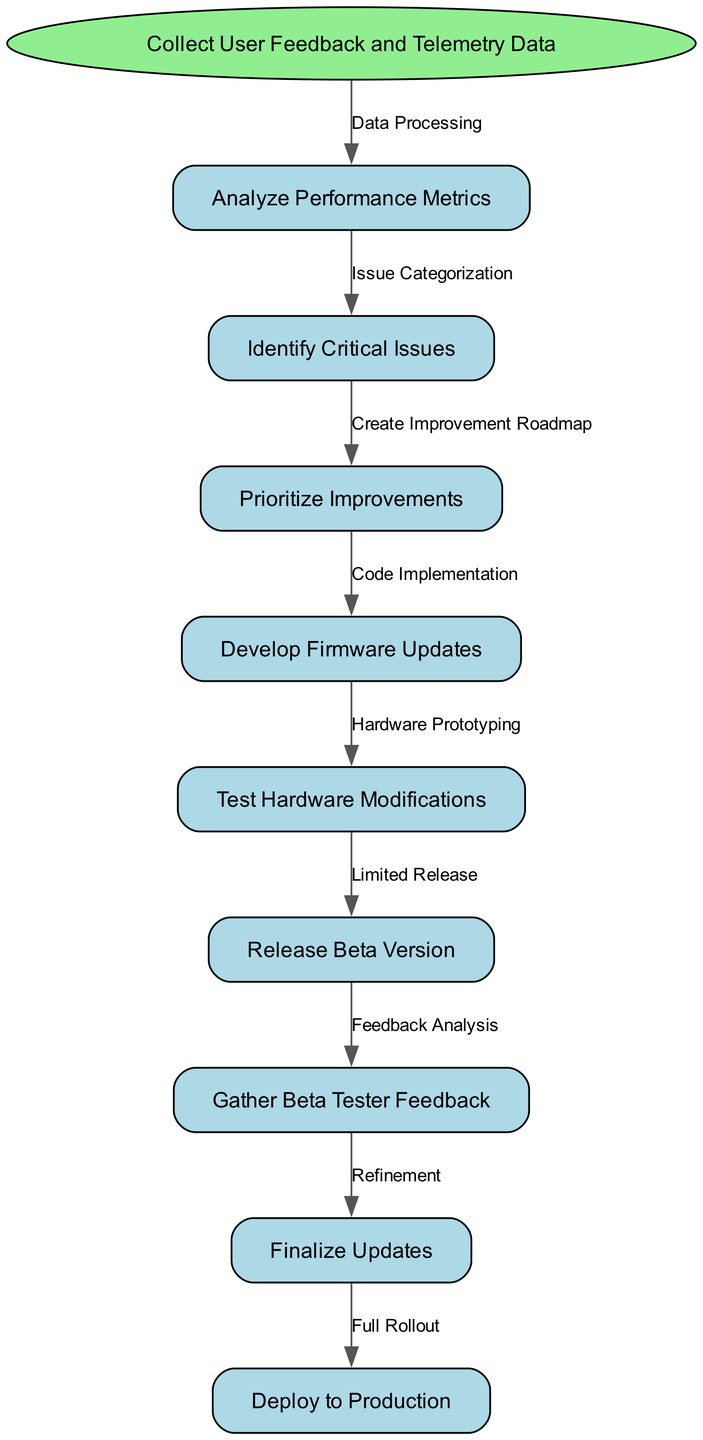What is the starting point of the workflow? The diagram indicates that the workflow begins with the node labeled "Collect User Feedback and Telemetry Data". This is the first step represented as an oval shape, showing where the process initiates.
Answer: Collect User Feedback and Telemetry Data How many nodes are in the diagram? To find the total number of nodes, we count the start node and all nodes listed in the nodes array. There is 1 start node and 8 additional nodes in total, making it 9 nodes.
Answer: 9 Which node follows "Analyze Performance Metrics"? Looking at the edges connecting the nodes, "Analyze Performance Metrics" directly leads to "Identify Critical Issues". This is the immediate next step in the workflow after performance metrics are analyzed.
Answer: Identify Critical Issues What is the last step in the optimization workflow? The final node in the workflow is indicated by the last connection, which is "Deploy to Production". This shows that after all previous steps are completed, the last action taken is deploying the final updates to the product.
Answer: Deploy to Production Which node is linked to "Release Beta Version"? In the diagram, "Release Beta Version" is connected to the node "Gather Beta Tester Feedback". This means that after releasing a beta version, the next action is to gather feedback from beta testers.
Answer: Gather Beta Tester Feedback How many edges are there in the diagram? By counting the connections between the nodes, we see there are 8 edges that connect the 9 nodes together, indicating the flow of the process.
Answer: 8 What is the relationship between "Test Hardware Modifications" and "Finalize Updates"? "Test Hardware Modifications" leads to "Finalize Updates", creating a direct correlation where after modifications are tested, the updates are finalized. This illustrates the progression of refining the product.
Answer: Finalize Updates Identify the process that happens after "Prioritize Improvements". Following the node "Prioritize Improvements", the next action in the sequence is "Develop Firmware Updates", indicating that improvements are prioritized before the development of firmware takes place.
Answer: Develop Firmware Updates How do we categorize issues after analyzing performance metrics? The relationship outlined in the diagram shows that "Analyze Performance Metrics" leads to "Identify Critical Issues", implying this is the step where issues are categorized based on the performance analysis.
Answer: Identify Critical Issues 